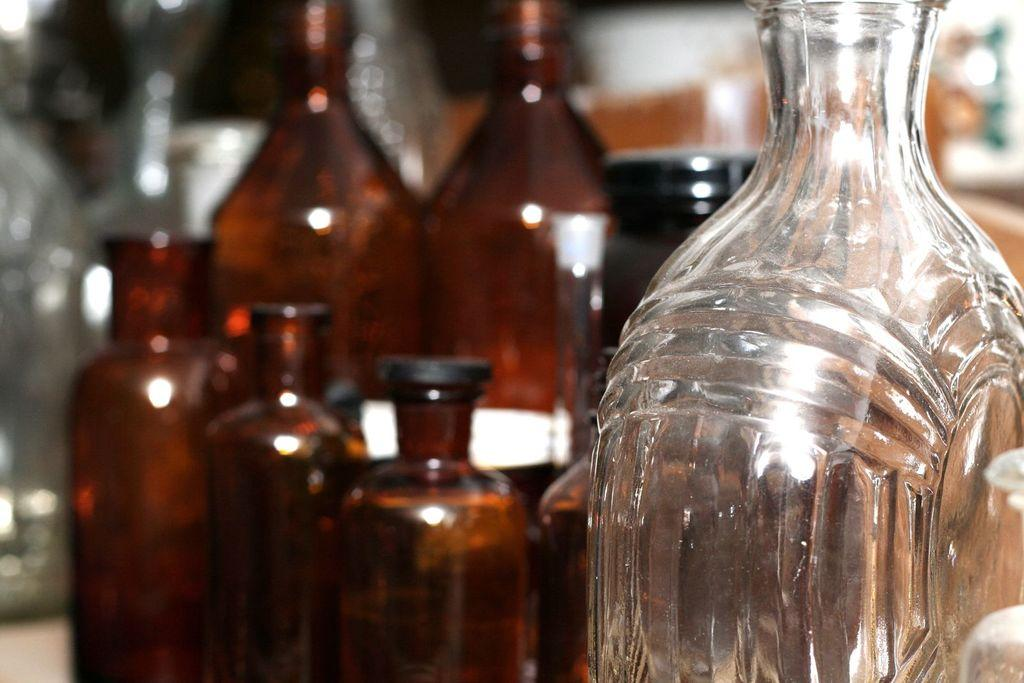What type of bottle is visible in the image? There is a wine bottle in the image. How many bottles are present in the image? There are multiple bottles in the image. Can you describe the clarity of the image? The image is blurry. How many ladybugs can be seen on the truck in the image? There is no truck or ladybugs present in the image. 